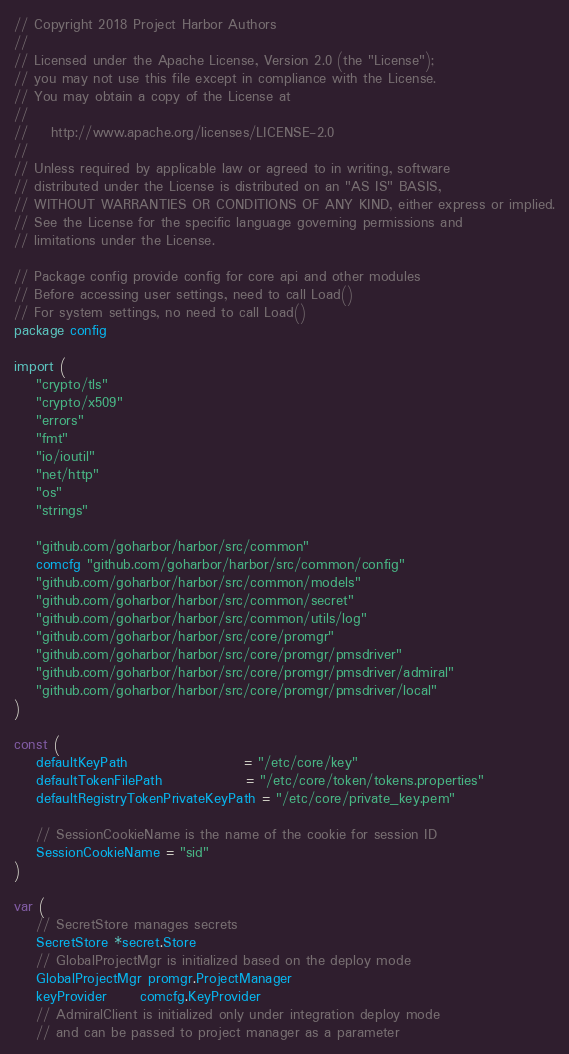Convert code to text. <code><loc_0><loc_0><loc_500><loc_500><_Go_>// Copyright 2018 Project Harbor Authors
//
// Licensed under the Apache License, Version 2.0 (the "License");
// you may not use this file except in compliance with the License.
// You may obtain a copy of the License at
//
//    http://www.apache.org/licenses/LICENSE-2.0
//
// Unless required by applicable law or agreed to in writing, software
// distributed under the License is distributed on an "AS IS" BASIS,
// WITHOUT WARRANTIES OR CONDITIONS OF ANY KIND, either express or implied.
// See the License for the specific language governing permissions and
// limitations under the License.

// Package config provide config for core api and other modules
// Before accessing user settings, need to call Load()
// For system settings, no need to call Load()
package config

import (
	"crypto/tls"
	"crypto/x509"
	"errors"
	"fmt"
	"io/ioutil"
	"net/http"
	"os"
	"strings"

	"github.com/goharbor/harbor/src/common"
	comcfg "github.com/goharbor/harbor/src/common/config"
	"github.com/goharbor/harbor/src/common/models"
	"github.com/goharbor/harbor/src/common/secret"
	"github.com/goharbor/harbor/src/common/utils/log"
	"github.com/goharbor/harbor/src/core/promgr"
	"github.com/goharbor/harbor/src/core/promgr/pmsdriver"
	"github.com/goharbor/harbor/src/core/promgr/pmsdriver/admiral"
	"github.com/goharbor/harbor/src/core/promgr/pmsdriver/local"
)

const (
	defaultKeyPath                     = "/etc/core/key"
	defaultTokenFilePath               = "/etc/core/token/tokens.properties"
	defaultRegistryTokenPrivateKeyPath = "/etc/core/private_key.pem"

	// SessionCookieName is the name of the cookie for session ID
	SessionCookieName = "sid"
)

var (
	// SecretStore manages secrets
	SecretStore *secret.Store
	// GlobalProjectMgr is initialized based on the deploy mode
	GlobalProjectMgr promgr.ProjectManager
	keyProvider      comcfg.KeyProvider
	// AdmiralClient is initialized only under integration deploy mode
	// and can be passed to project manager as a parameter</code> 